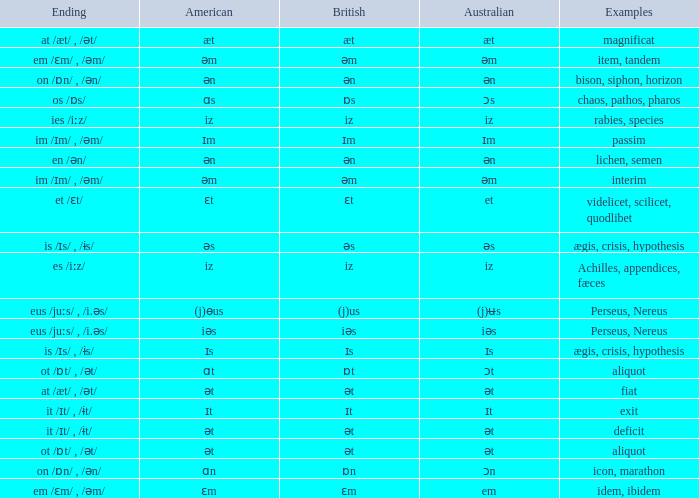Which Ending has British of iz, and Examples of achilles, appendices, fæces? Es /iːz/. 